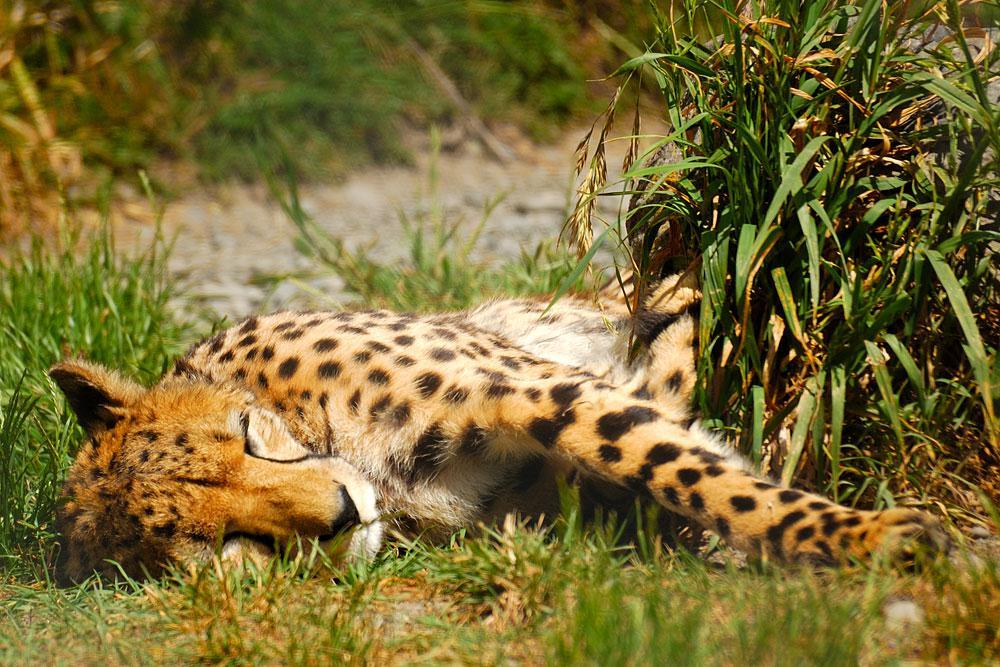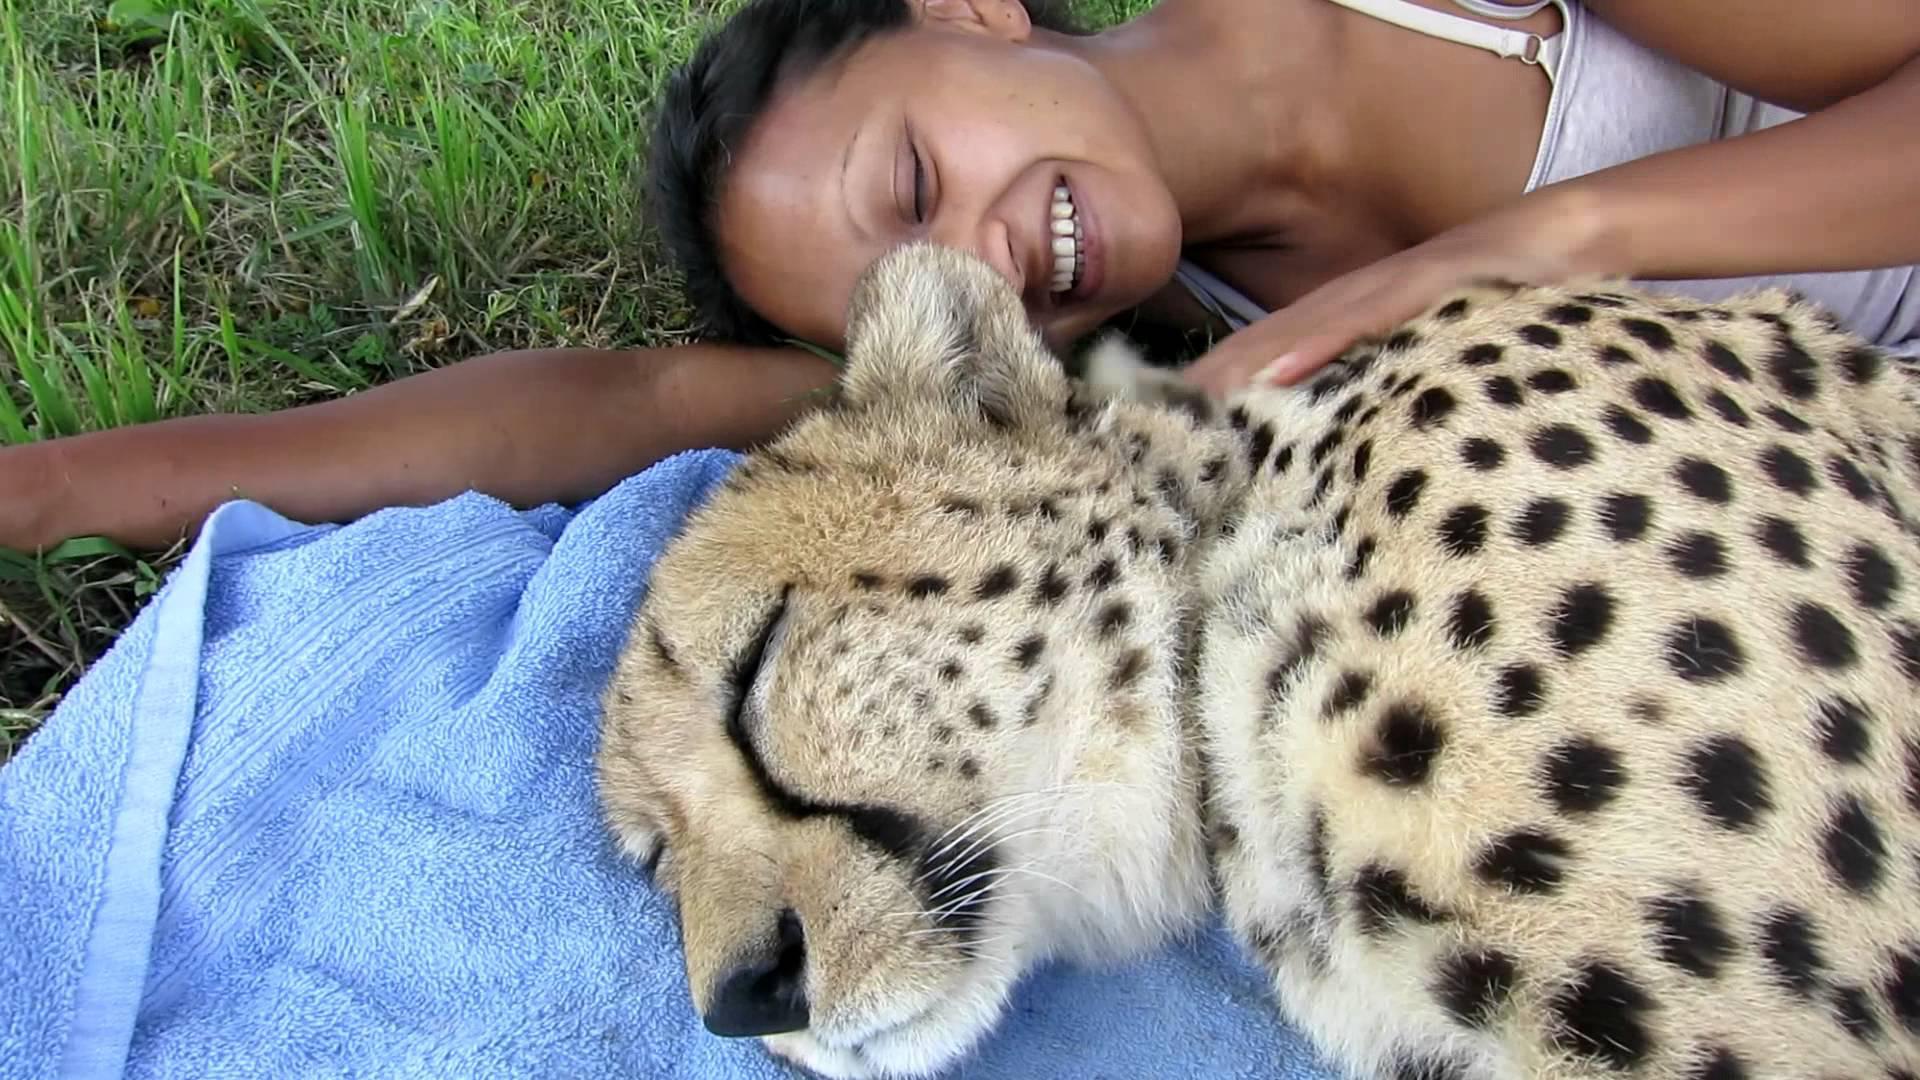The first image is the image on the left, the second image is the image on the right. Assess this claim about the two images: "One of the cheetahs is yawning". Correct or not? Answer yes or no. No. The first image is the image on the left, the second image is the image on the right. For the images shown, is this caption "The cat in the image on the right has its mouth open wide." true? Answer yes or no. No. 